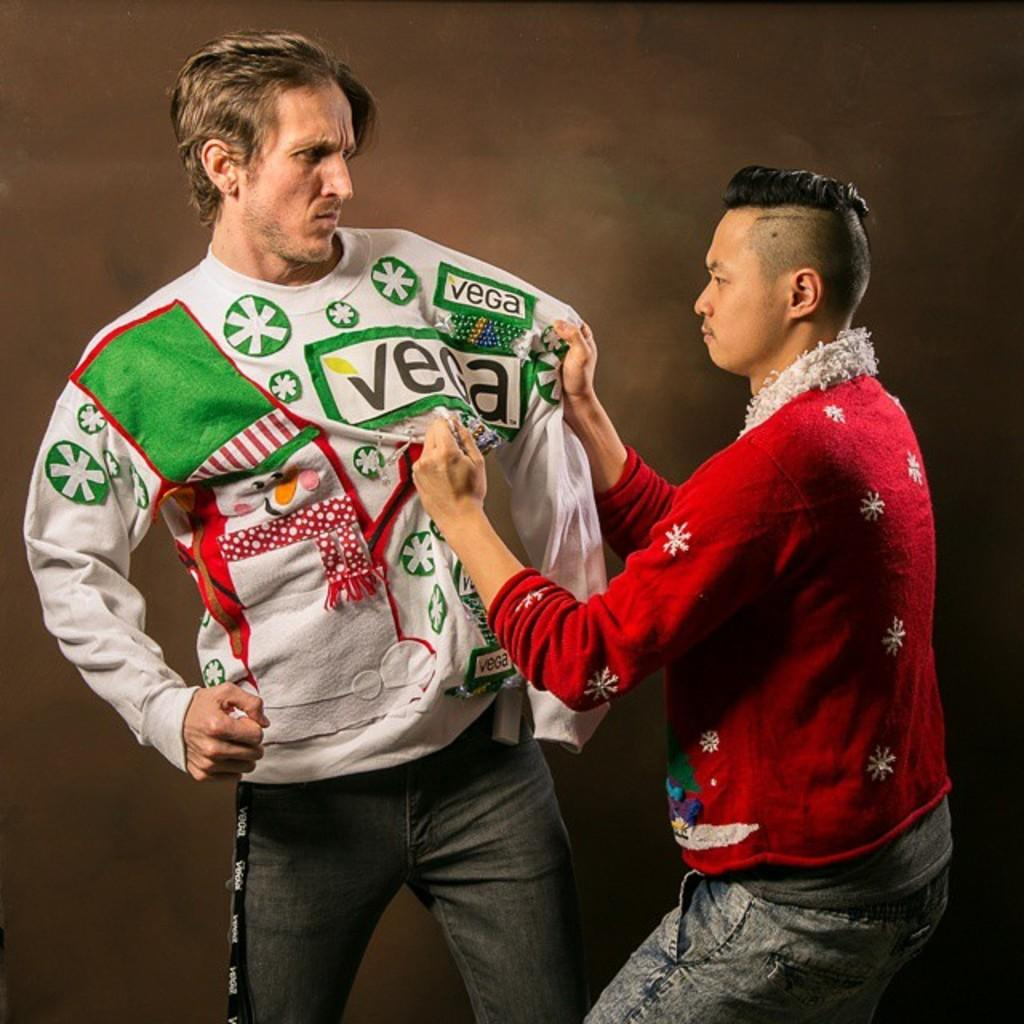<image>
Relay a brief, clear account of the picture shown. A man wears a white sweater with the VEGA logo while another man wears red. 